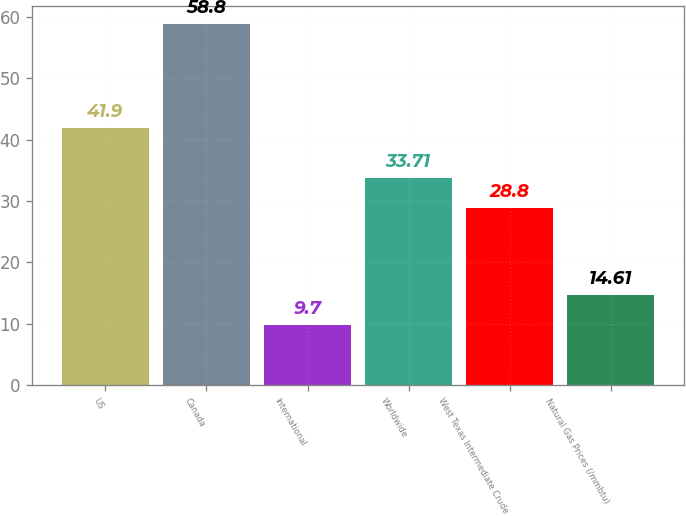Convert chart to OTSL. <chart><loc_0><loc_0><loc_500><loc_500><bar_chart><fcel>US<fcel>Canada<fcel>International<fcel>Worldwide<fcel>West Texas Intermediate Crude<fcel>Natural Gas Prices (/mmbtu)<nl><fcel>41.9<fcel>58.8<fcel>9.7<fcel>33.71<fcel>28.8<fcel>14.61<nl></chart> 